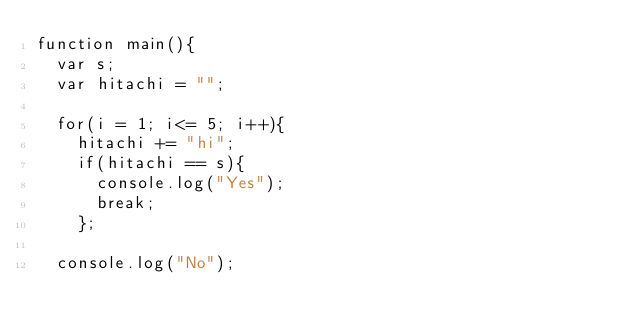Convert code to text. <code><loc_0><loc_0><loc_500><loc_500><_JavaScript_>function main(){
  var s;
  var hitachi = "";
  
  for(i = 1; i<= 5; i++){
    hitachi += "hi";
    if(hitachi == s){
      console.log("Yes");
      break;	
    };
  
  console.log("No");
    

</code> 